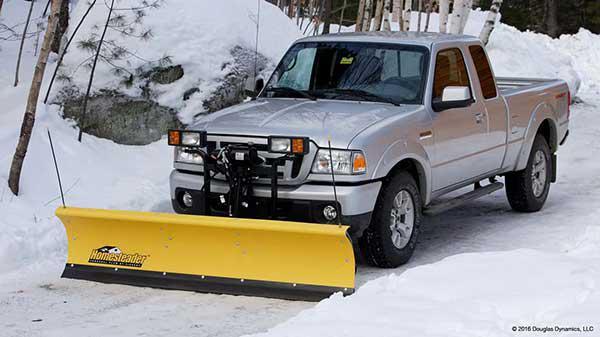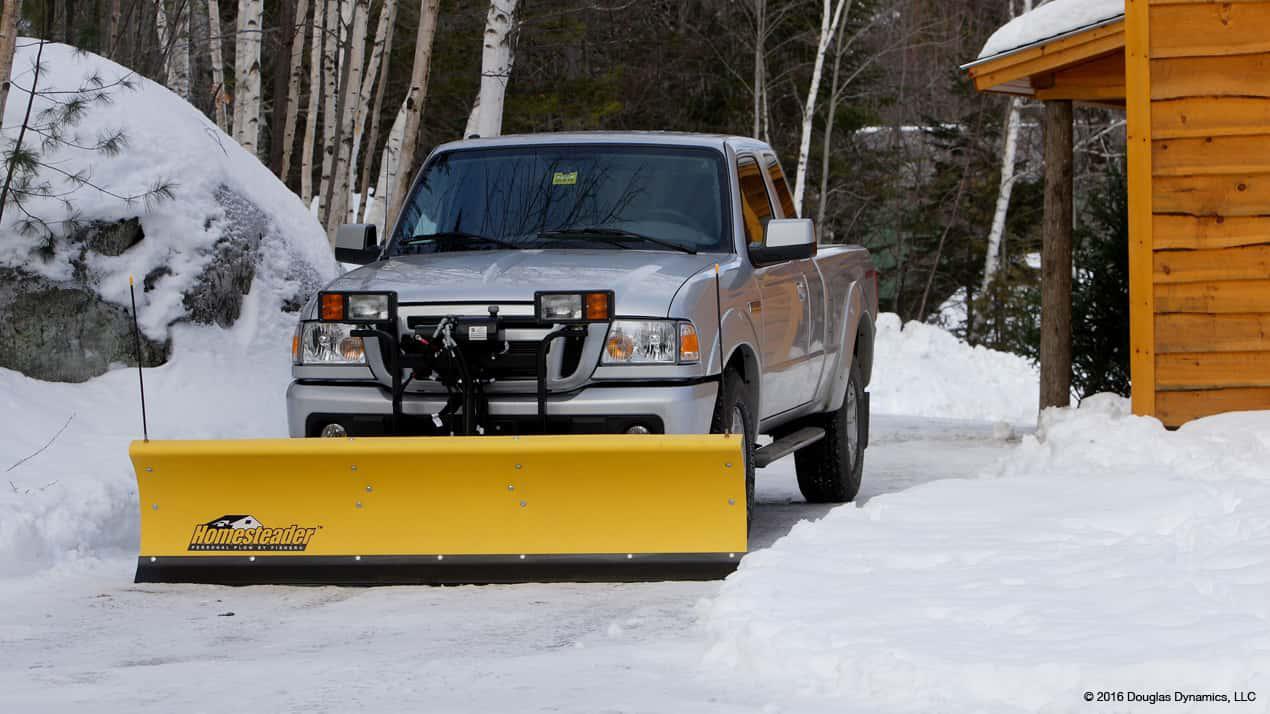The first image is the image on the left, the second image is the image on the right. Analyze the images presented: Is the assertion "A blue vehicle is pushing a yellow plow in the image on the left." valid? Answer yes or no. No. The first image is the image on the left, the second image is the image on the right. Analyze the images presented: Is the assertion "Each image shows one gray truck equipped with a bright yellow snow plow and parked on snowy ground." valid? Answer yes or no. Yes. 